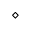Convert formula to latex. <formula><loc_0><loc_0><loc_500><loc_500>\diamond</formula> 